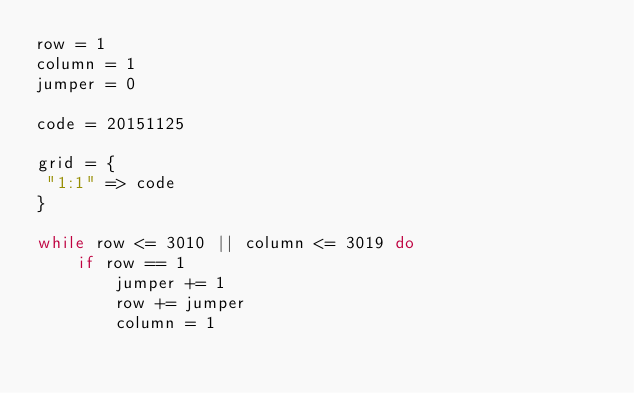Convert code to text. <code><loc_0><loc_0><loc_500><loc_500><_Ruby_>row = 1
column = 1
jumper = 0

code = 20151125

grid = {
 "1:1" => code
}

while row <= 3010 || column <= 3019 do
    if row == 1
        jumper += 1
        row += jumper
        column = 1</code> 